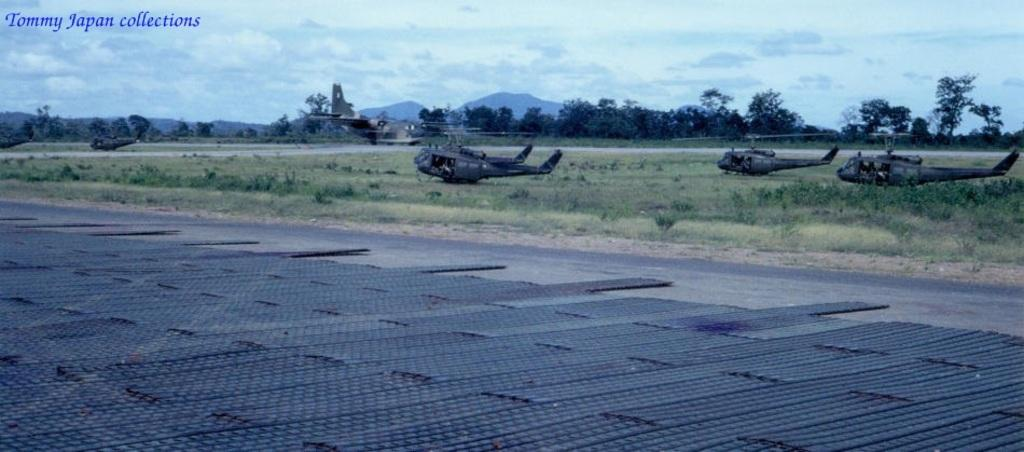How many helicopters can be seen on the grassland in the image? There are three helicopters on the grassland in the image. What other type of aircraft is visible in the image? There is an aeroplane on the runway in the background. What can be seen in the distance behind the helicopters? Hills and trees are visible in the background. What is the condition of the sky in the image? The sky is visible with clouds in the image. What word is being spelled out by the helicopters in the image? There is no word being spelled out by the helicopters in the image; they are simply parked on the grassland. How are the helicopters and aeroplane distributed across the image? The helicopters are on the grassland, while the aeroplane is on the runway in the background. There is no specific distribution pattern mentioned in the facts. 